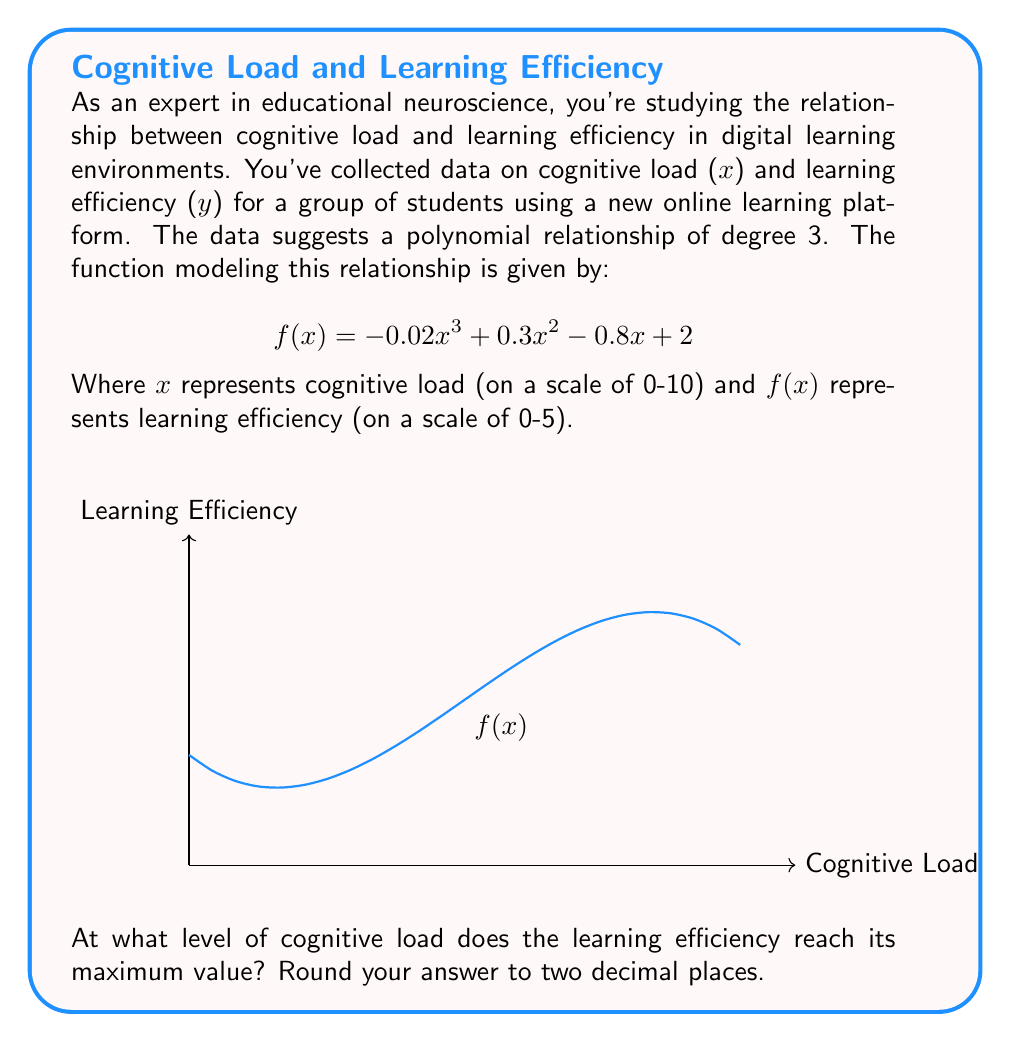Can you solve this math problem? To find the maximum value of the function, we need to follow these steps:

1) First, we need to find the derivative of the function:
   $$ f'(x) = -0.06x^2 + 0.6x - 0.8 $$

2) Set the derivative equal to zero to find the critical points:
   $$ -0.06x^2 + 0.6x - 0.8 = 0 $$

3) This is a quadratic equation. We can solve it using the quadratic formula:
   $$ x = \frac{-b \pm \sqrt{b^2 - 4ac}}{2a} $$
   Where $a = -0.06$, $b = 0.6$, and $c = -0.8$

4) Plugging in these values:
   $$ x = \frac{-0.6 \pm \sqrt{0.6^2 - 4(-0.06)(-0.8)}}{2(-0.06)} $$
   $$ = \frac{-0.6 \pm \sqrt{0.36 - 0.192}}{-0.12} $$
   $$ = \frac{-0.6 \pm \sqrt{0.168}}{-0.12} $$
   $$ = \frac{-0.6 \pm 0.41}{-0.12} $$

5) This gives us two solutions:
   $$ x_1 = \frac{-0.6 + 0.41}{-0.12} \approx 1.58 $$
   $$ x_2 = \frac{-0.6 - 0.41}{-0.12} \approx 8.42 $$

6) To determine which of these gives the maximum value, we can check the second derivative:
   $$ f''(x) = -0.12x + 0.6 $$

7) Evaluating this at our critical points:
   $$ f''(1.58) = -0.12(1.58) + 0.6 \approx 0.41 > 0 $$
   $$ f''(8.42) = -0.12(8.42) + 0.6 \approx -0.41 < 0 $$

8) Since the second derivative is negative at x ≈ 8.42, this is the point of maximum learning efficiency.

Therefore, the learning efficiency reaches its maximum value when the cognitive load is approximately 8.42.
Answer: 8.42 